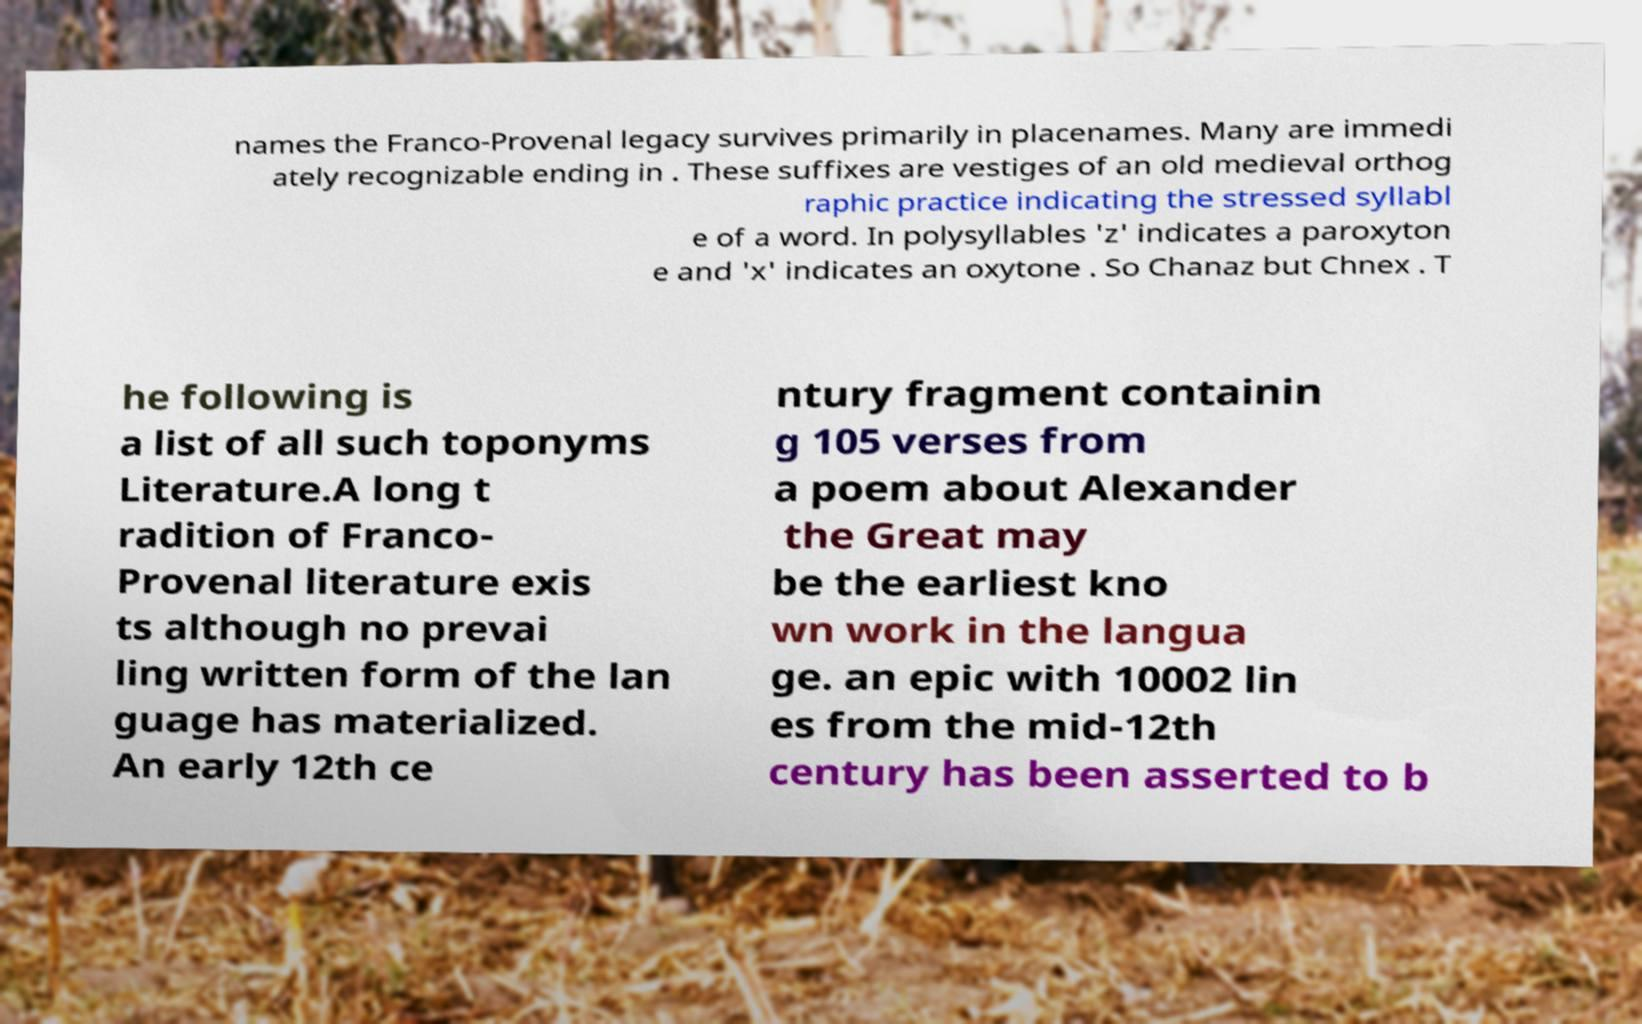For documentation purposes, I need the text within this image transcribed. Could you provide that? names the Franco-Provenal legacy survives primarily in placenames. Many are immedi ately recognizable ending in . These suffixes are vestiges of an old medieval orthog raphic practice indicating the stressed syllabl e of a word. In polysyllables 'z' indicates a paroxyton e and 'x' indicates an oxytone . So Chanaz but Chnex . T he following is a list of all such toponyms Literature.A long t radition of Franco- Provenal literature exis ts although no prevai ling written form of the lan guage has materialized. An early 12th ce ntury fragment containin g 105 verses from a poem about Alexander the Great may be the earliest kno wn work in the langua ge. an epic with 10002 lin es from the mid-12th century has been asserted to b 